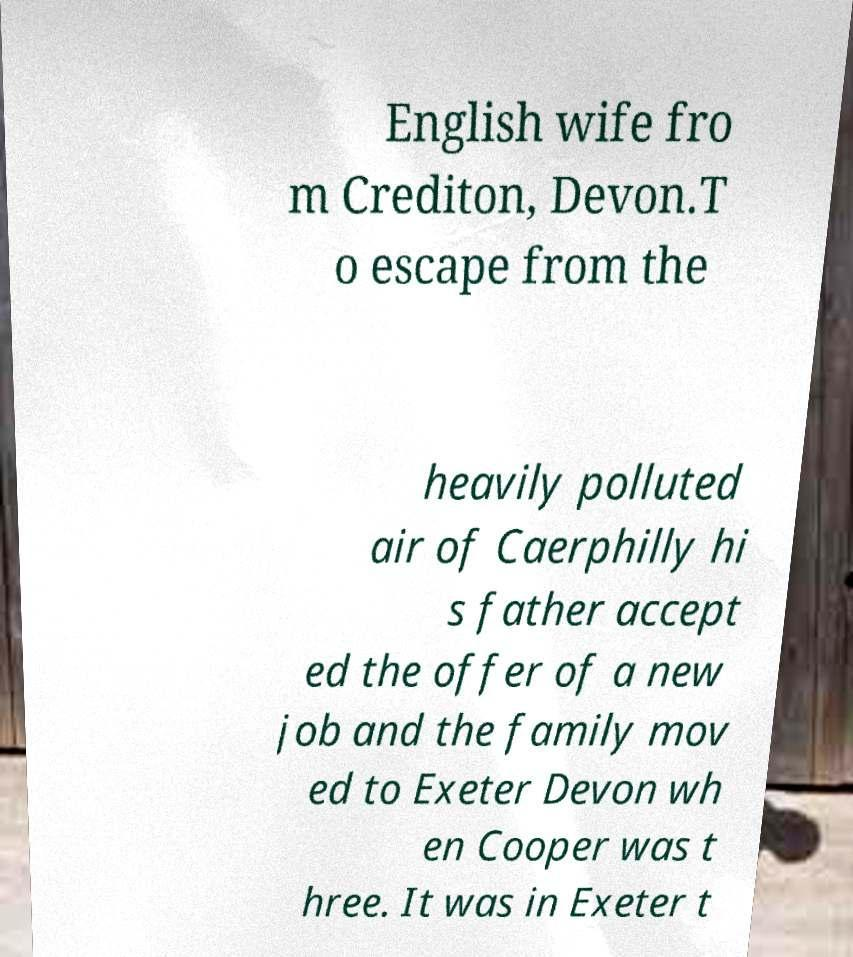I need the written content from this picture converted into text. Can you do that? English wife fro m Crediton, Devon.T o escape from the heavily polluted air of Caerphilly hi s father accept ed the offer of a new job and the family mov ed to Exeter Devon wh en Cooper was t hree. It was in Exeter t 